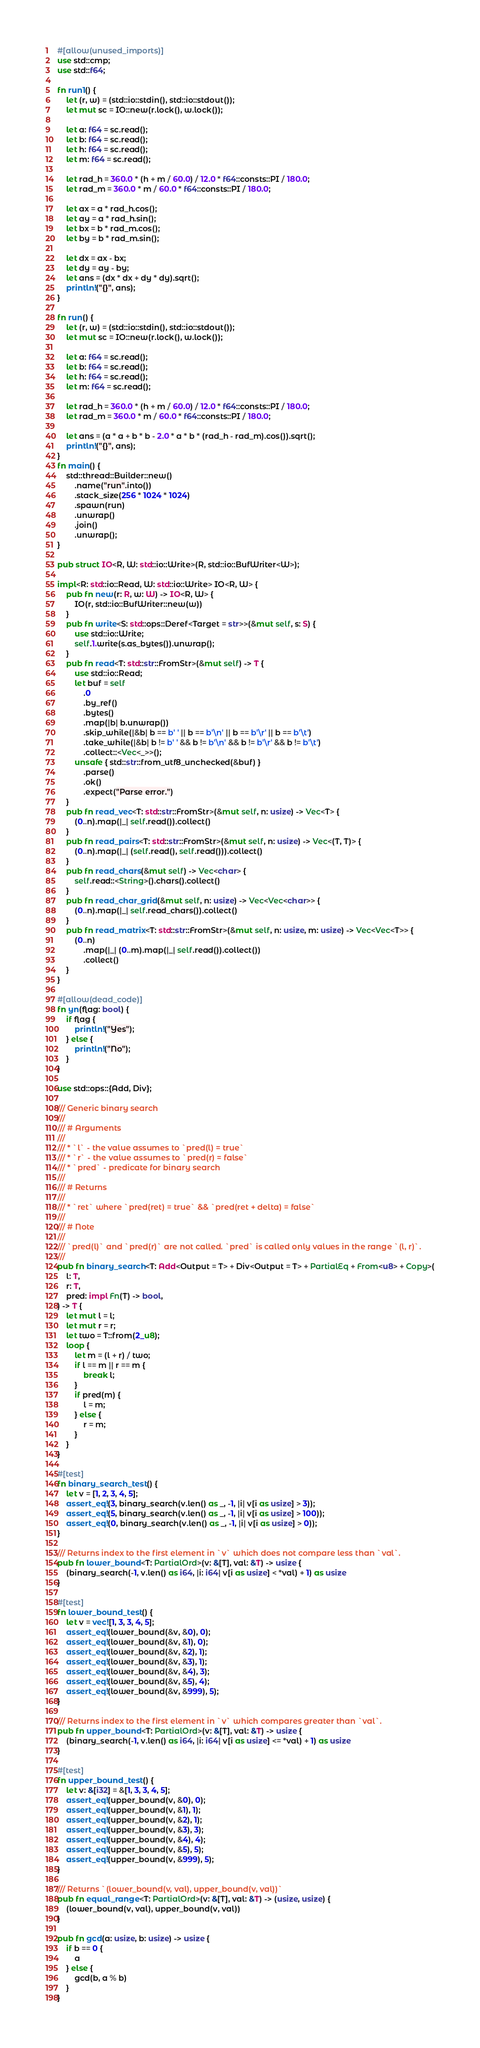<code> <loc_0><loc_0><loc_500><loc_500><_Rust_>#[allow(unused_imports)]
use std::cmp;
use std::f64;

fn run1() {
    let (r, w) = (std::io::stdin(), std::io::stdout());
    let mut sc = IO::new(r.lock(), w.lock());

    let a: f64 = sc.read();
    let b: f64 = sc.read();
    let h: f64 = sc.read();
    let m: f64 = sc.read();

    let rad_h = 360.0 * (h + m / 60.0) / 12.0 * f64::consts::PI / 180.0;
    let rad_m = 360.0 * m / 60.0 * f64::consts::PI / 180.0;

    let ax = a * rad_h.cos();
    let ay = a * rad_h.sin();
    let bx = b * rad_m.cos();
    let by = b * rad_m.sin();

    let dx = ax - bx;
    let dy = ay - by;
    let ans = (dx * dx + dy * dy).sqrt();
    println!("{}", ans);
}

fn run() {
    let (r, w) = (std::io::stdin(), std::io::stdout());
    let mut sc = IO::new(r.lock(), w.lock());

    let a: f64 = sc.read();
    let b: f64 = sc.read();
    let h: f64 = sc.read();
    let m: f64 = sc.read();

    let rad_h = 360.0 * (h + m / 60.0) / 12.0 * f64::consts::PI / 180.0;
    let rad_m = 360.0 * m / 60.0 * f64::consts::PI / 180.0;

    let ans = (a * a + b * b - 2.0 * a * b * (rad_h - rad_m).cos()).sqrt();
    println!("{}", ans);
}
fn main() {
    std::thread::Builder::new()
        .name("run".into())
        .stack_size(256 * 1024 * 1024)
        .spawn(run)
        .unwrap()
        .join()
        .unwrap();
}

pub struct IO<R, W: std::io::Write>(R, std::io::BufWriter<W>);

impl<R: std::io::Read, W: std::io::Write> IO<R, W> {
    pub fn new(r: R, w: W) -> IO<R, W> {
        IO(r, std::io::BufWriter::new(w))
    }
    pub fn write<S: std::ops::Deref<Target = str>>(&mut self, s: S) {
        use std::io::Write;
        self.1.write(s.as_bytes()).unwrap();
    }
    pub fn read<T: std::str::FromStr>(&mut self) -> T {
        use std::io::Read;
        let buf = self
            .0
            .by_ref()
            .bytes()
            .map(|b| b.unwrap())
            .skip_while(|&b| b == b' ' || b == b'\n' || b == b'\r' || b == b'\t')
            .take_while(|&b| b != b' ' && b != b'\n' && b != b'\r' && b != b'\t')
            .collect::<Vec<_>>();
        unsafe { std::str::from_utf8_unchecked(&buf) }
            .parse()
            .ok()
            .expect("Parse error.")
    }
    pub fn read_vec<T: std::str::FromStr>(&mut self, n: usize) -> Vec<T> {
        (0..n).map(|_| self.read()).collect()
    }
    pub fn read_pairs<T: std::str::FromStr>(&mut self, n: usize) -> Vec<(T, T)> {
        (0..n).map(|_| (self.read(), self.read())).collect()
    }
    pub fn read_chars(&mut self) -> Vec<char> {
        self.read::<String>().chars().collect()
    }
    pub fn read_char_grid(&mut self, n: usize) -> Vec<Vec<char>> {
        (0..n).map(|_| self.read_chars()).collect()
    }
    pub fn read_matrix<T: std::str::FromStr>(&mut self, n: usize, m: usize) -> Vec<Vec<T>> {
        (0..n)
            .map(|_| (0..m).map(|_| self.read()).collect())
            .collect()
    }
}

#[allow(dead_code)]
fn yn(flag: bool) {
    if flag {
        println!("Yes");
    } else {
        println!("No");
    }
}

use std::ops::{Add, Div};

/// Generic binary search
///
/// # Arguments
///
/// * `l` - the value assumes to `pred(l) = true`
/// * `r` - the value assumes to `pred(r) = false`
/// * `pred` - predicate for binary search
///
/// # Returns
///
/// * `ret` where `pred(ret) = true` && `pred(ret + delta) = false`
///
/// # Note
///
/// `pred(l)` and `pred(r)` are not called. `pred` is called only values in the range `(l, r)`.
///
pub fn binary_search<T: Add<Output = T> + Div<Output = T> + PartialEq + From<u8> + Copy>(
    l: T,
    r: T,
    pred: impl Fn(T) -> bool,
) -> T {
    let mut l = l;
    let mut r = r;
    let two = T::from(2_u8);
    loop {
        let m = (l + r) / two;
        if l == m || r == m {
            break l;
        }
        if pred(m) {
            l = m;
        } else {
            r = m;
        }
    }
}

#[test]
fn binary_search_test() {
    let v = [1, 2, 3, 4, 5];
    assert_eq!(3, binary_search(v.len() as _, -1, |i| v[i as usize] > 3));
    assert_eq!(5, binary_search(v.len() as _, -1, |i| v[i as usize] > 100));
    assert_eq!(0, binary_search(v.len() as _, -1, |i| v[i as usize] > 0));
}

/// Returns index to the first element in `v` which does not compare less than `val`.
pub fn lower_bound<T: PartialOrd>(v: &[T], val: &T) -> usize {
    (binary_search(-1, v.len() as i64, |i: i64| v[i as usize] < *val) + 1) as usize
}

#[test]
fn lower_bound_test() {
    let v = vec![1, 3, 3, 4, 5];
    assert_eq!(lower_bound(&v, &0), 0);
    assert_eq!(lower_bound(&v, &1), 0);
    assert_eq!(lower_bound(&v, &2), 1);
    assert_eq!(lower_bound(&v, &3), 1);
    assert_eq!(lower_bound(&v, &4), 3);
    assert_eq!(lower_bound(&v, &5), 4);
    assert_eq!(lower_bound(&v, &999), 5);
}

/// Returns index to the first element in `v` which compares greater than `val`.
pub fn upper_bound<T: PartialOrd>(v: &[T], val: &T) -> usize {
    (binary_search(-1, v.len() as i64, |i: i64| v[i as usize] <= *val) + 1) as usize
}

#[test]
fn upper_bound_test() {
    let v: &[i32] = &[1, 3, 3, 4, 5];
    assert_eq!(upper_bound(v, &0), 0);
    assert_eq!(upper_bound(v, &1), 1);
    assert_eq!(upper_bound(v, &2), 1);
    assert_eq!(upper_bound(v, &3), 3);
    assert_eq!(upper_bound(v, &4), 4);
    assert_eq!(upper_bound(v, &5), 5);
    assert_eq!(upper_bound(v, &999), 5);
}

/// Returns `(lower_bound(v, val), upper_bound(v, val))`
pub fn equal_range<T: PartialOrd>(v: &[T], val: &T) -> (usize, usize) {
    (lower_bound(v, val), upper_bound(v, val))
}

pub fn gcd(a: usize, b: usize) -> usize {
    if b == 0 {
        a
    } else {
        gcd(b, a % b)
    }
}
</code> 